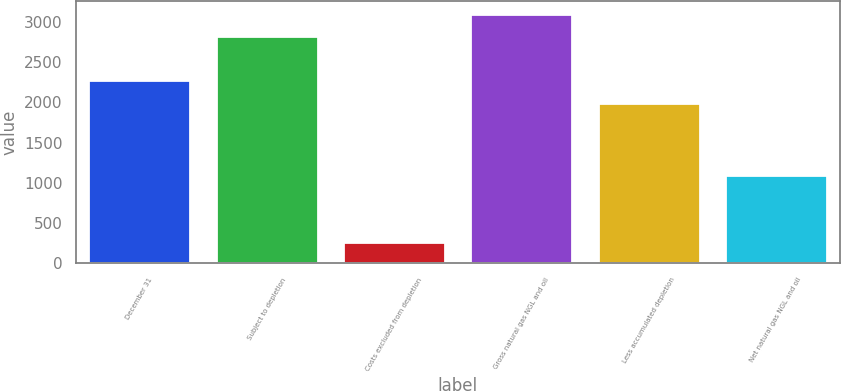Convert chart to OTSL. <chart><loc_0><loc_0><loc_500><loc_500><bar_chart><fcel>December 31<fcel>Subject to depletion<fcel>Costs excluded from depletion<fcel>Gross natural gas NGL and oil<fcel>Less accumulated depletion<fcel>Net natural gas NGL and oil<nl><fcel>2272.8<fcel>2818<fcel>272<fcel>3099.8<fcel>1991<fcel>1099<nl></chart> 